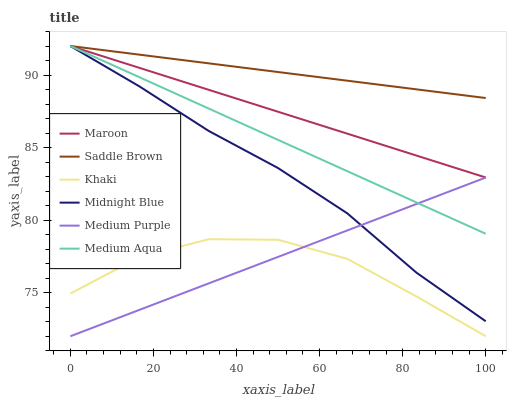Does Midnight Blue have the minimum area under the curve?
Answer yes or no. No. Does Midnight Blue have the maximum area under the curve?
Answer yes or no. No. Is Midnight Blue the smoothest?
Answer yes or no. No. Is Midnight Blue the roughest?
Answer yes or no. No. Does Midnight Blue have the lowest value?
Answer yes or no. No. Does Medium Purple have the highest value?
Answer yes or no. No. Is Khaki less than Saddle Brown?
Answer yes or no. Yes. Is Saddle Brown greater than Medium Purple?
Answer yes or no. Yes. Does Khaki intersect Saddle Brown?
Answer yes or no. No. 